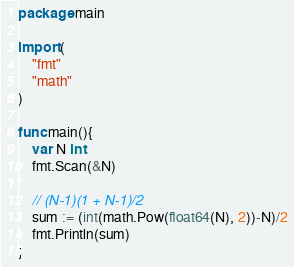Convert code to text. <code><loc_0><loc_0><loc_500><loc_500><_Go_>package main

import (
	"fmt"
	"math"
)

func main(){
	var N int
	fmt.Scan(&N)

	// (N-1)(1 + N-1)/2
	sum := (int(math.Pow(float64(N), 2))-N)/2
	fmt.Println(sum)
}
</code> 